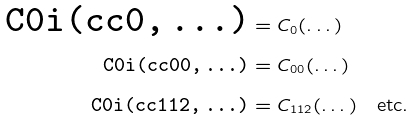<formula> <loc_0><loc_0><loc_500><loc_500>\text {\tt C0i(cc0,\,\dots)} & = C _ { 0 } ( \dots ) \\ \text {\tt C0i(cc00,\,\dots)} & = C _ { 0 0 } ( \dots ) \\ \text {\tt C0i(cc112,\,\dots)} & = C _ { 1 1 2 } ( \dots ) \quad \text {etc.}</formula> 